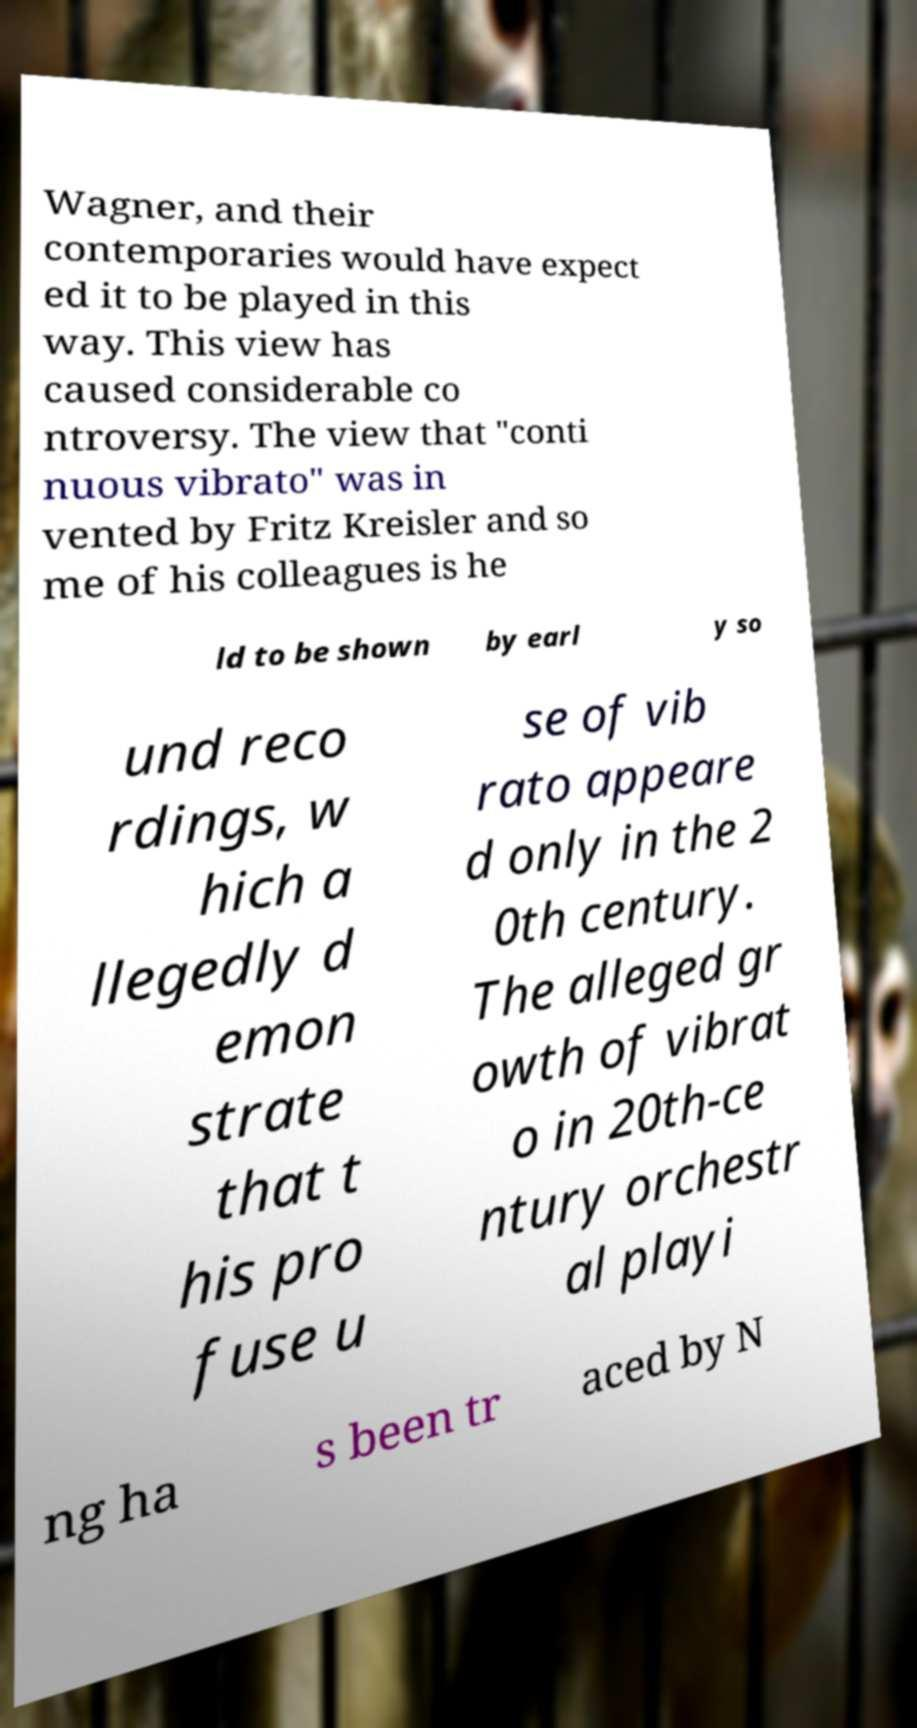Please identify and transcribe the text found in this image. Wagner, and their contemporaries would have expect ed it to be played in this way. This view has caused considerable co ntroversy. The view that "conti nuous vibrato" was in vented by Fritz Kreisler and so me of his colleagues is he ld to be shown by earl y so und reco rdings, w hich a llegedly d emon strate that t his pro fuse u se of vib rato appeare d only in the 2 0th century. The alleged gr owth of vibrat o in 20th-ce ntury orchestr al playi ng ha s been tr aced by N 